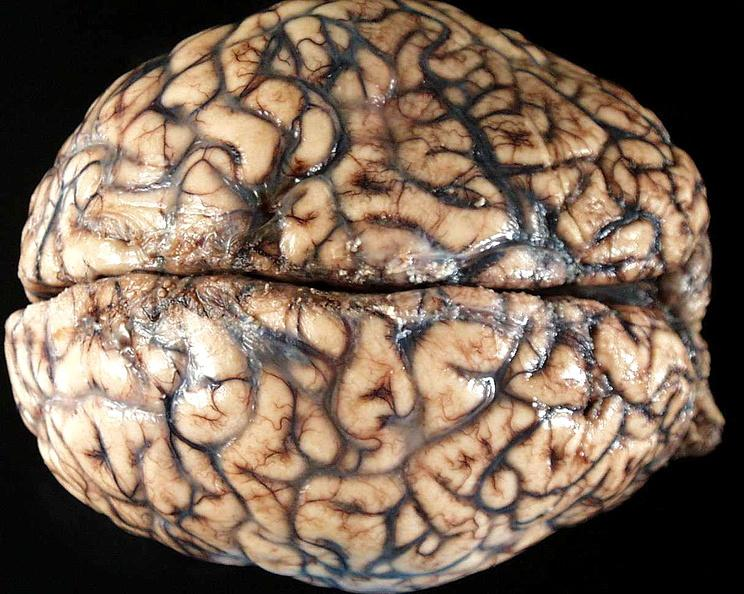what does this image show?
Answer the question using a single word or phrase. Brain 